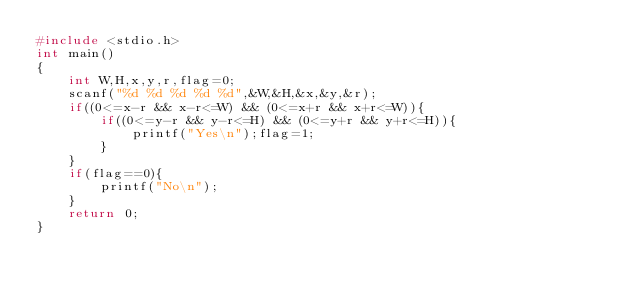Convert code to text. <code><loc_0><loc_0><loc_500><loc_500><_C_>#include <stdio.h>
int main()
{
	int W,H,x,y,r,flag=0;
	scanf("%d %d %d %d %d",&W,&H,&x,&y,&r);
	if((0<=x-r && x-r<=W) && (0<=x+r && x+r<=W)){
		if((0<=y-r && y-r<=H) && (0<=y+r && y+r<=H)){
			printf("Yes\n");flag=1;
		}
	}
	if(flag==0){
		printf("No\n");
	}
	return 0;
}</code> 